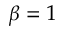Convert formula to latex. <formula><loc_0><loc_0><loc_500><loc_500>\beta = 1</formula> 